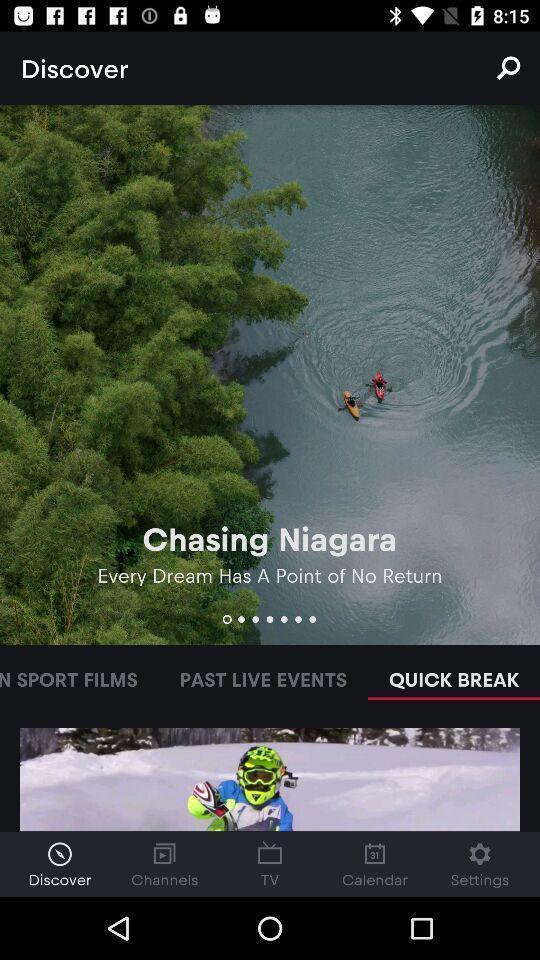Describe the visual elements of this screenshot. Page shows the discovering options of favorite places. 